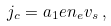<formula> <loc_0><loc_0><loc_500><loc_500>j _ { c } = a _ { 1 } e n _ { e } v _ { s } \, ,</formula> 